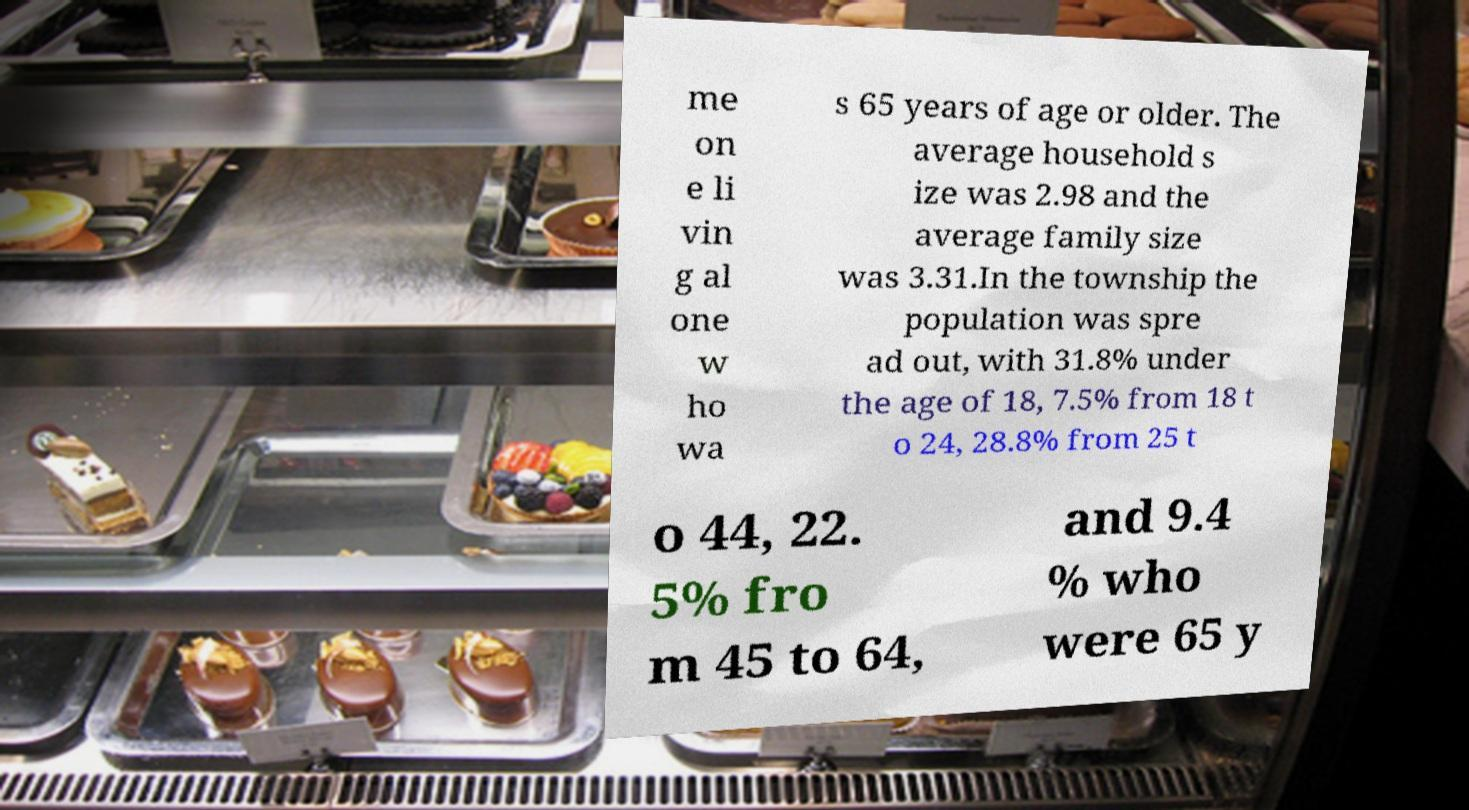There's text embedded in this image that I need extracted. Can you transcribe it verbatim? me on e li vin g al one w ho wa s 65 years of age or older. The average household s ize was 2.98 and the average family size was 3.31.In the township the population was spre ad out, with 31.8% under the age of 18, 7.5% from 18 t o 24, 28.8% from 25 t o 44, 22. 5% fro m 45 to 64, and 9.4 % who were 65 y 